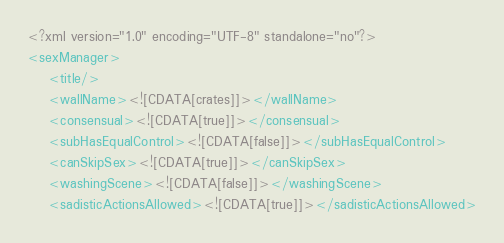<code> <loc_0><loc_0><loc_500><loc_500><_XML_><?xml version="1.0" encoding="UTF-8" standalone="no"?>
<sexManager>
	<title/>
	<wallName><![CDATA[crates]]></wallName>
	<consensual><![CDATA[true]]></consensual>
	<subHasEqualControl><![CDATA[false]]></subHasEqualControl>
	<canSkipSex><![CDATA[true]]></canSkipSex>
	<washingScene><![CDATA[false]]></washingScene>
	<sadisticActionsAllowed><![CDATA[true]]></sadisticActionsAllowed></code> 